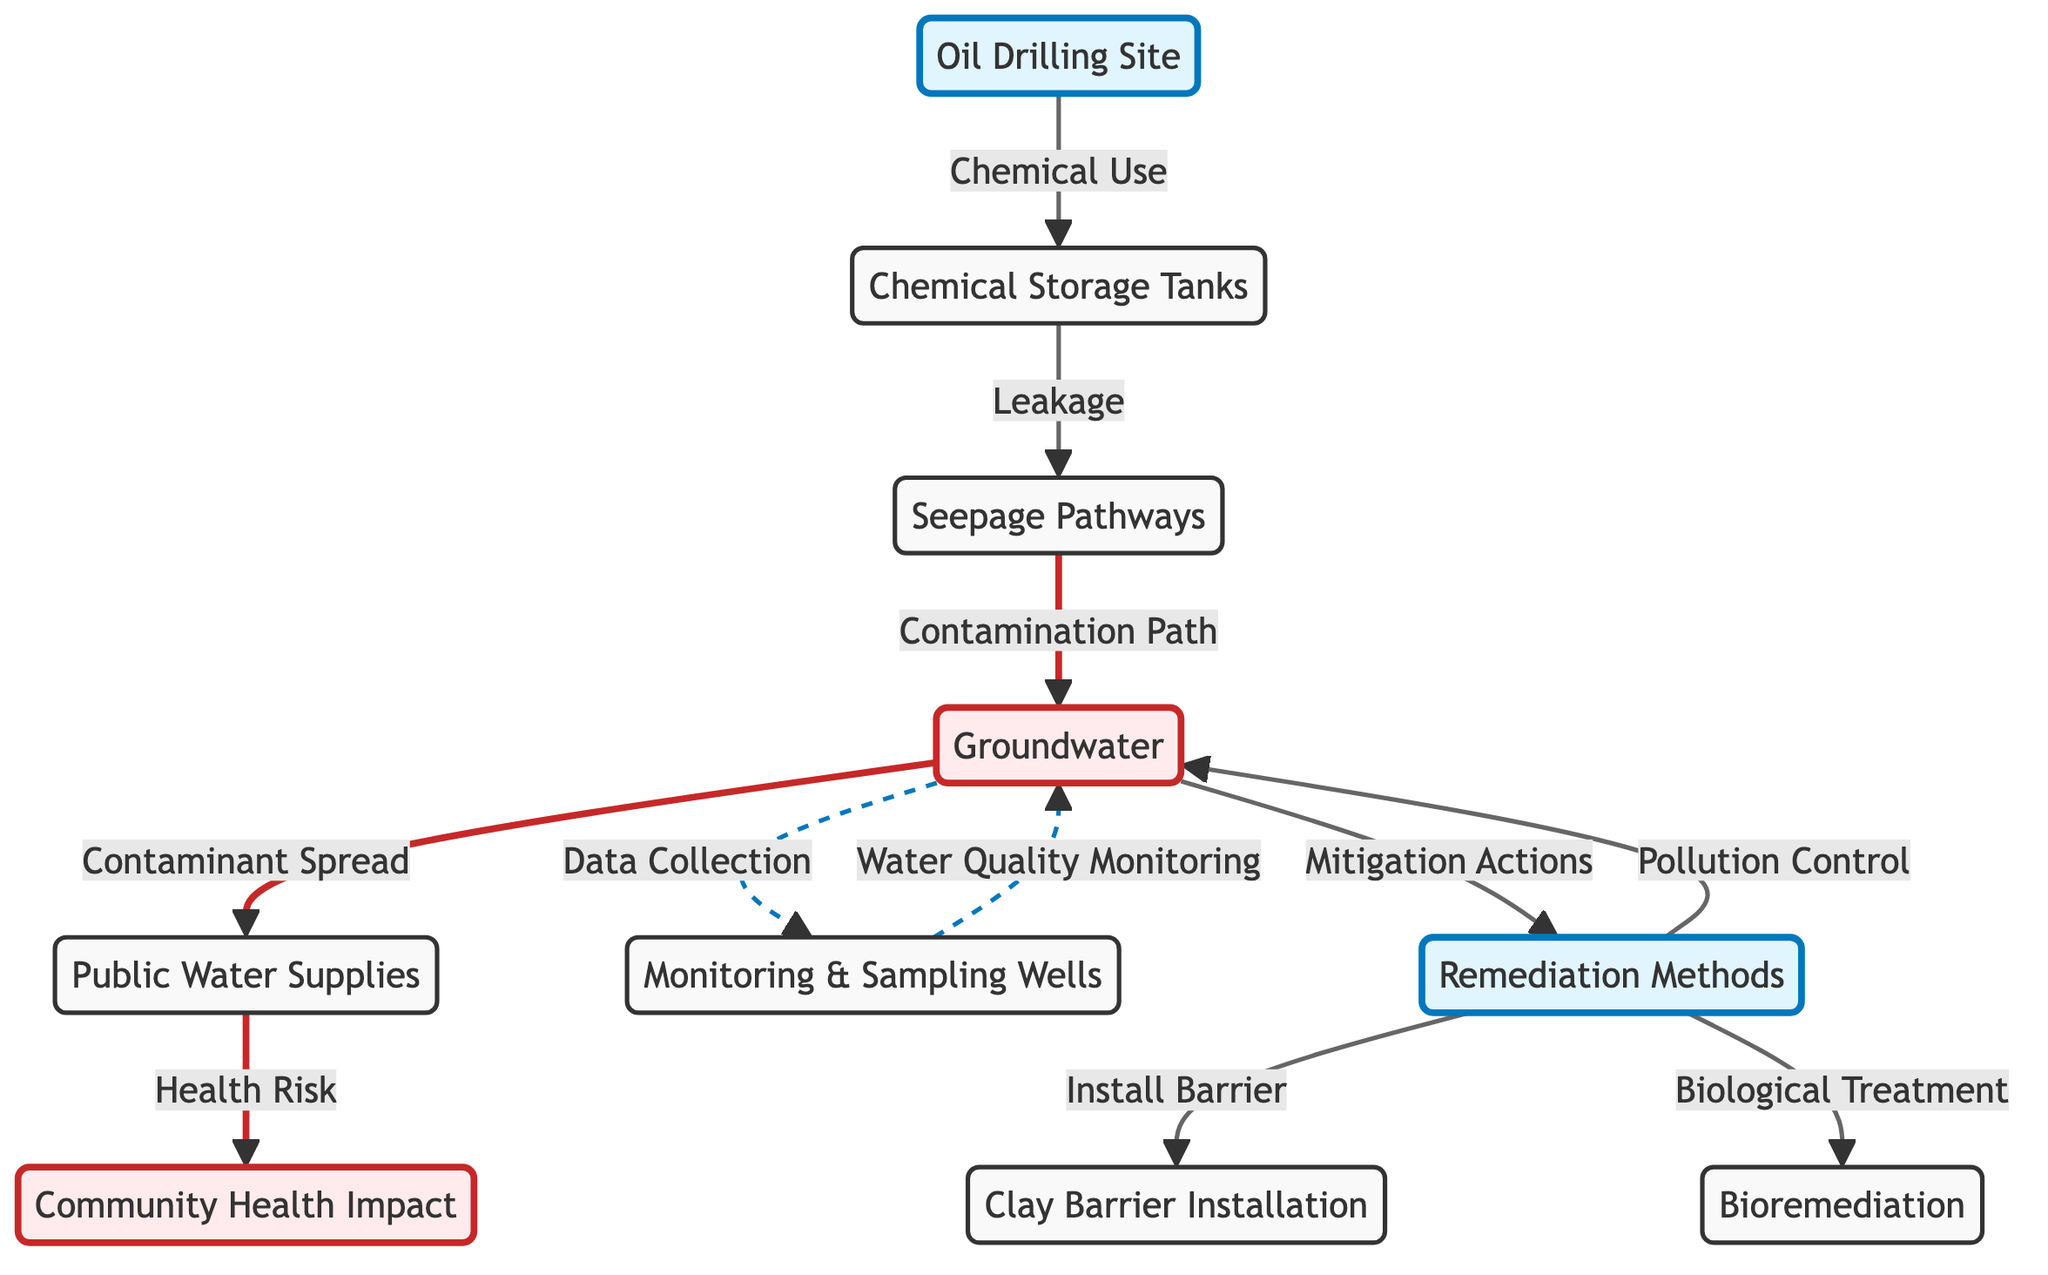What is the starting point of the chemical seepage pathway? The diagram indicates that the starting point for the chemical seepage pathway is the Oil Drilling Site. This can be seen as the initial node that connects to the chemical storage tanks, which are noted to cause leakage into the seepage pathways.
Answer: Oil Drilling Site How many contamination paths lead from groundwater to public water supplies? The diagram shows a single arrow from groundwater to public water supplies, indicating one direct contamination path. Thus, the answer is based on the direct connection shown in the diagram.
Answer: 1 What method is indicated for pollution control in groundwater? The remediation methods node connects to groundwater and is labeled "Pollution Control." This suggests that various strategies for mitigating pollution exist within that node. The simplest method explicitly listed is the installation of a clay barrier, as shown in the diagram.
Answer: Pollution Control What two strategies are suggested for groundwater remediation? The remediation methods node branches out to two specific strategies: the installation of a clay barrier and bioremediation. Both are shown as distinct pathways from the remediation methods node.
Answer: Clay Barrier Installation, Bioremediation Which node represents the health impacts associated with contaminated public water supplies? The community health node directly follows the public water supplies node and is connected by a labeled arrow indicating a health risk connection. Therefore, this node represents the health impacts associated with contamination.
Answer: Community Health Impact What is indicated as a monitoring strategy for groundwater quality? The sampling wells node is represented in a dashed line, indicating a monitoring strategy linked to groundwater for water quality assessments. This connection suggests a proactive approach toward assessing contamination risks.
Answer: Monitoring & Sampling Wells Which component indicates the potential path for contaminant spread? The contaminant spread is represented in the diagram by the arrow leading from groundwater to public water supplies, clearly labeled "Contaminant Spread." This indicates that contamination can travel through this pathway.
Answer: Contaminant Spread How many nodes directly link to groundwater? The diagram shows three nodes that have direct connections to groundwater: public water supplies, remediation methods, and sampling wells. Thus, counting these direct relationships provides the total.
Answer: 3 What type of health risk is associated with chemicals in public water supplies? The link between public water supplies and community health is explicitly labeled as a "Health Risk," indicating the concern regarding contamination effects on community wellbeing.
Answer: Health Risk 